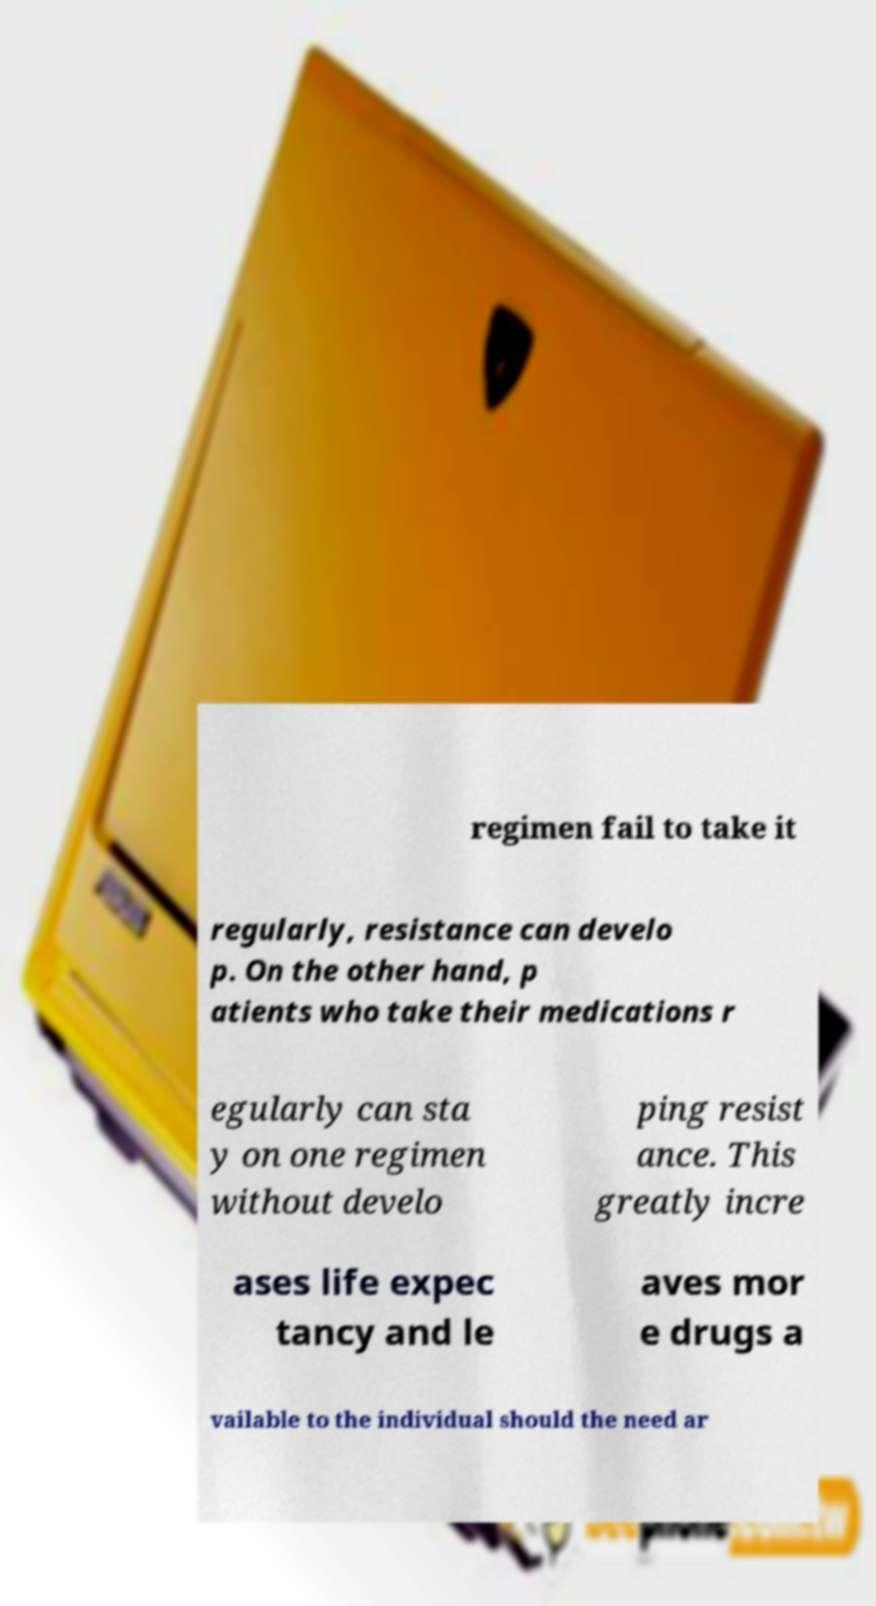Could you extract and type out the text from this image? regimen fail to take it regularly, resistance can develo p. On the other hand, p atients who take their medications r egularly can sta y on one regimen without develo ping resist ance. This greatly incre ases life expec tancy and le aves mor e drugs a vailable to the individual should the need ar 